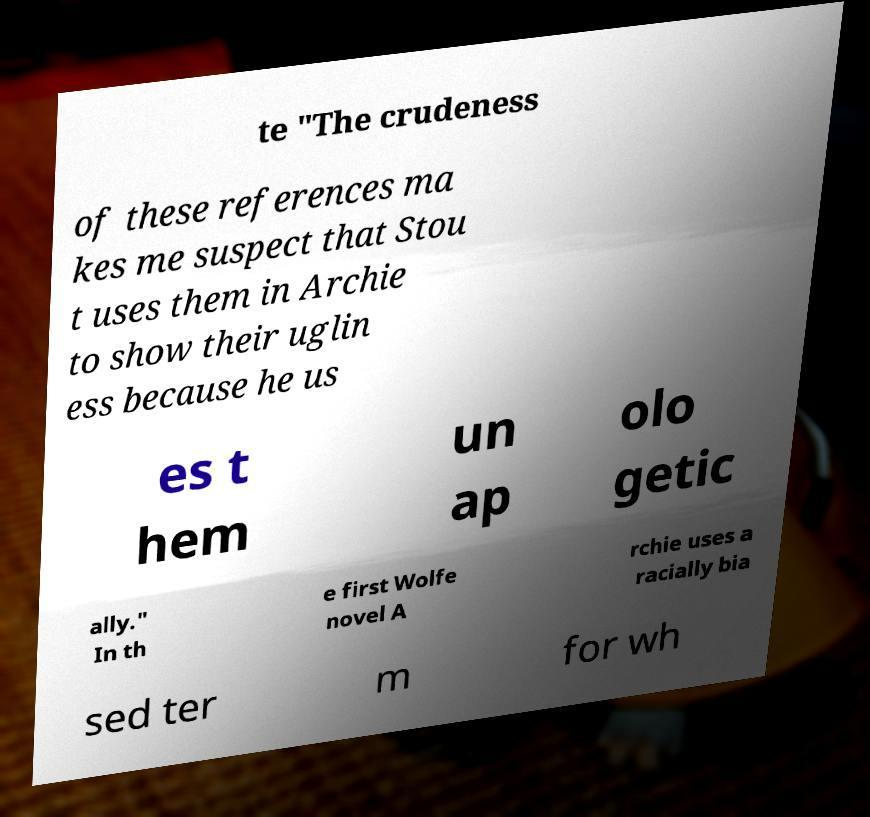Can you read and provide the text displayed in the image?This photo seems to have some interesting text. Can you extract and type it out for me? te "The crudeness of these references ma kes me suspect that Stou t uses them in Archie to show their uglin ess because he us es t hem un ap olo getic ally." In th e first Wolfe novel A rchie uses a racially bia sed ter m for wh 